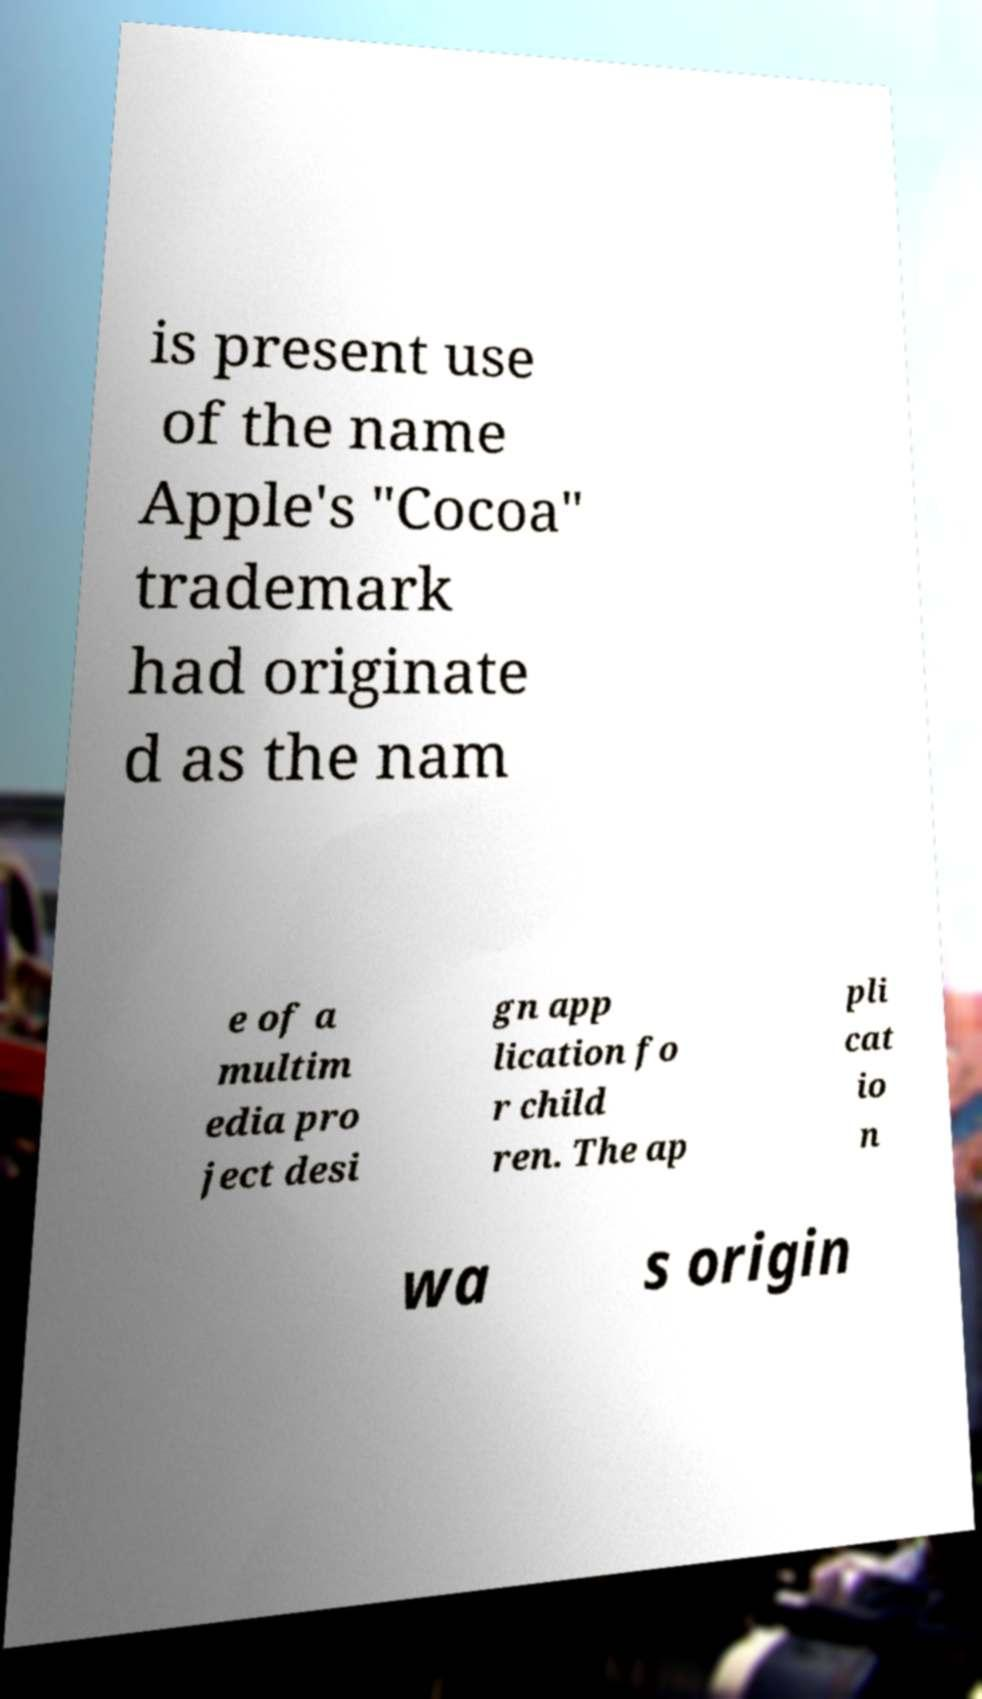Can you accurately transcribe the text from the provided image for me? is present use of the name Apple's "Cocoa" trademark had originate d as the nam e of a multim edia pro ject desi gn app lication fo r child ren. The ap pli cat io n wa s origin 